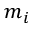<formula> <loc_0><loc_0><loc_500><loc_500>m _ { i }</formula> 